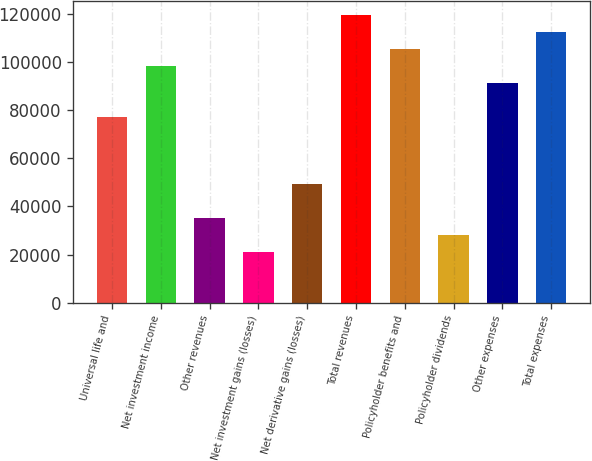<chart> <loc_0><loc_0><loc_500><loc_500><bar_chart><fcel>Universal life and<fcel>Net investment income<fcel>Other revenues<fcel>Net investment gains (losses)<fcel>Net derivative gains (losses)<fcel>Total revenues<fcel>Policyholder benefits and<fcel>Policyholder dividends<fcel>Other expenses<fcel>Total expenses<nl><fcel>77287.2<fcel>98362.8<fcel>35136<fcel>21085.6<fcel>49186.4<fcel>119438<fcel>105388<fcel>28110.8<fcel>91337.6<fcel>112413<nl></chart> 